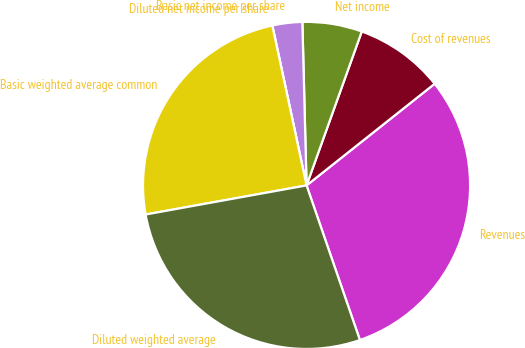Convert chart to OTSL. <chart><loc_0><loc_0><loc_500><loc_500><pie_chart><fcel>Revenues<fcel>Cost of revenues<fcel>Net income<fcel>Basic net income per share<fcel>Diluted net income per share<fcel>Basic weighted average common<fcel>Diluted weighted average<nl><fcel>30.39%<fcel>8.84%<fcel>5.89%<fcel>2.95%<fcel>0.0%<fcel>24.49%<fcel>27.44%<nl></chart> 